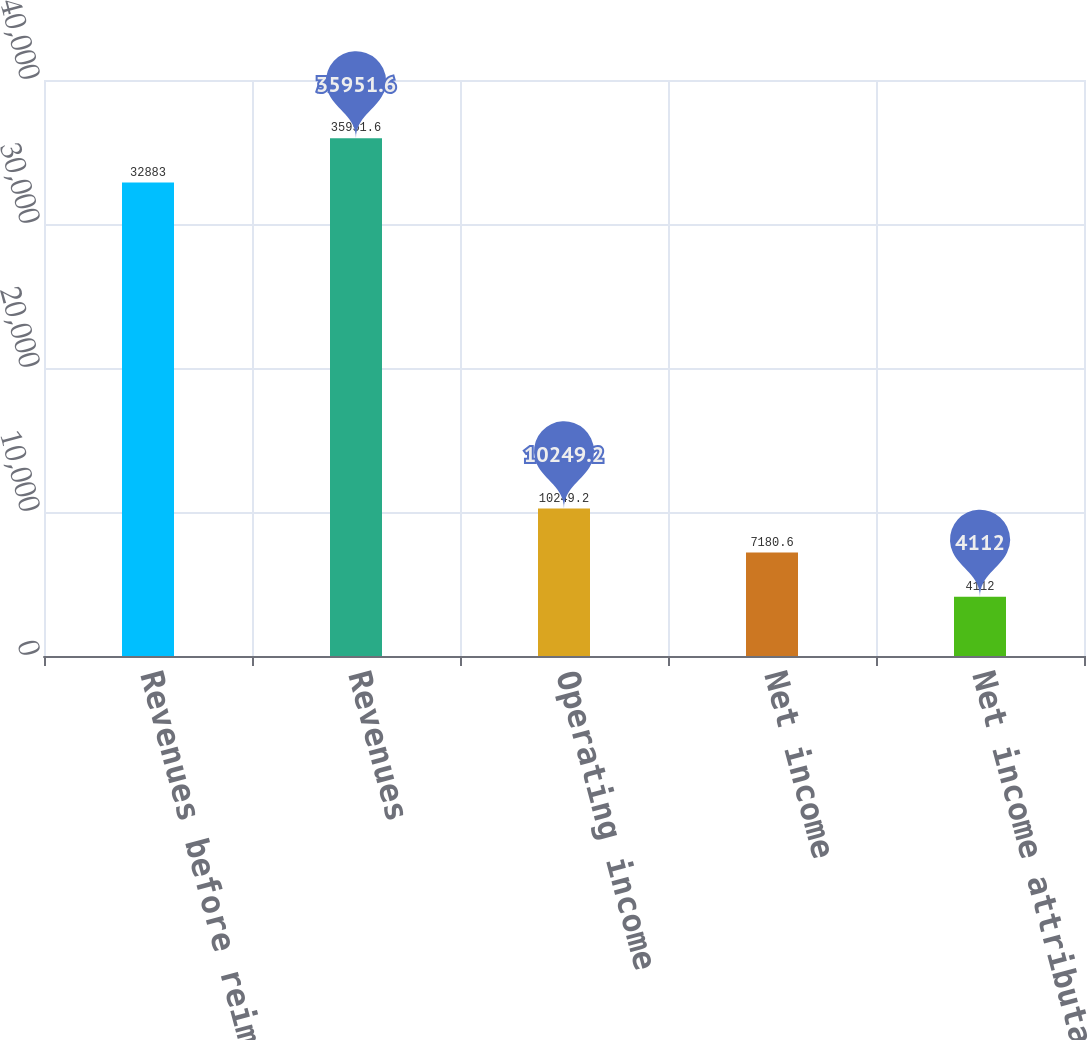Convert chart to OTSL. <chart><loc_0><loc_0><loc_500><loc_500><bar_chart><fcel>Revenues before reimbursements<fcel>Revenues<fcel>Operating income<fcel>Net income<fcel>Net income attributable to<nl><fcel>32883<fcel>35951.6<fcel>10249.2<fcel>7180.6<fcel>4112<nl></chart> 